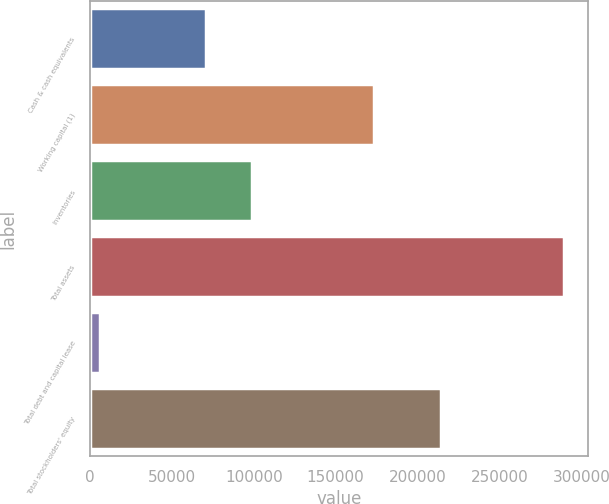Convert chart to OTSL. <chart><loc_0><loc_0><loc_500><loc_500><bar_chart><fcel>Cash & cash equivalents<fcel>Working capital (1)<fcel>Inventories<fcel>Total assets<fcel>Total debt and capital lease<fcel>Total stockholders' equity<nl><fcel>70655<fcel>173389<fcel>98966.1<fcel>289368<fcel>6257<fcel>214388<nl></chart> 